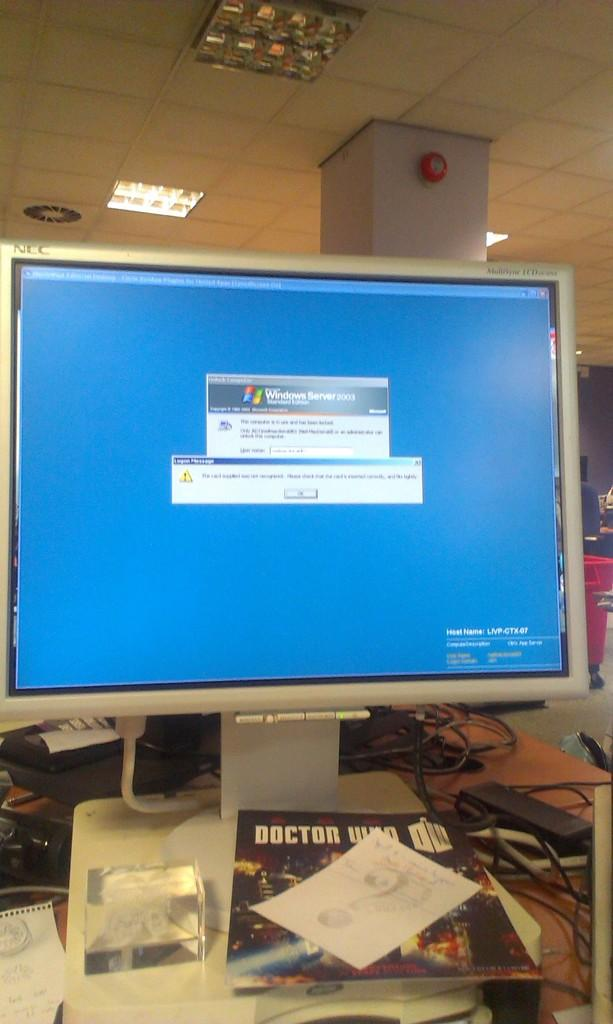<image>
Share a concise interpretation of the image provided. The operating system running is Microsoft Server 2003 